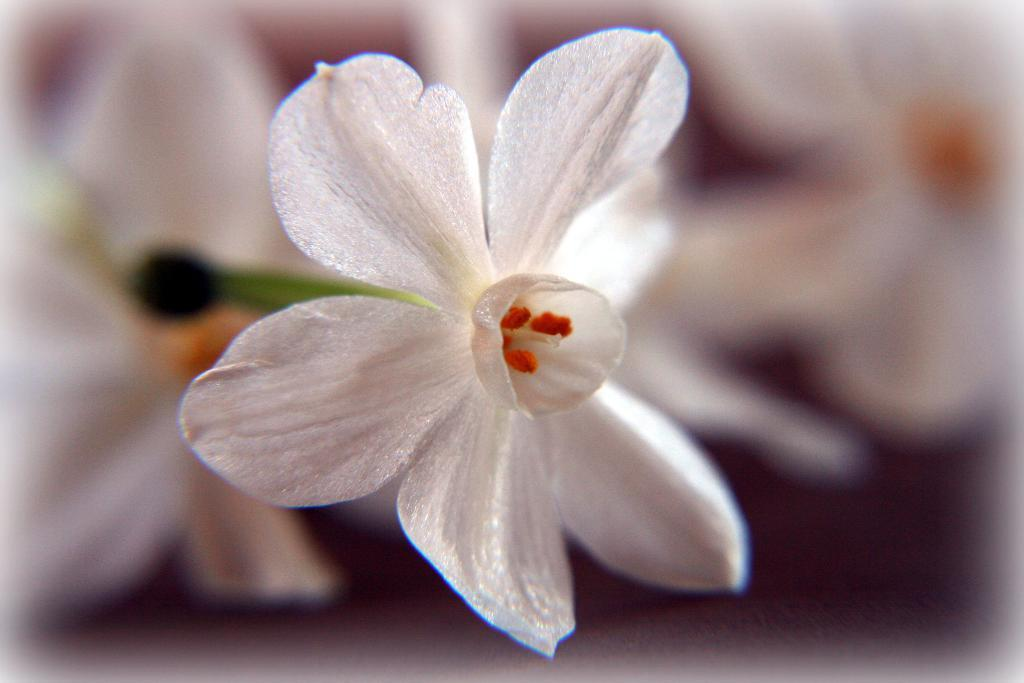What color is the flower in the image? The flower in the image is white-colored. What can be found in the center of the flower? Pollen grains are present in the middle of the flower. How does the flower beginner her journey in the image? There is no reference to a flower beginner in the image; it only features a white-colored flower with pollen grains in the center. 